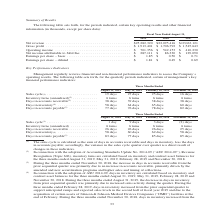According to Jabil Circuit's financial document, What was the net revenue in 2019? According to the financial document, $25,282,320 (in thousands). The relevant text states: "Net revenue . $25,282,320 $22,095,416 $19,063,121 Gross profit . $ 1,913,401 $ 1,706,792 $ 1,545,643 Operating income . $ 701,..." Also, What was the gross profit in 2018? According to the financial document, $1,706,792 (in thousands). The relevant text states: ",095,416 $19,063,121 Gross profit . $ 1,913,401 $ 1,706,792 $ 1,545,643 Operating income . $ 701,356 $ 542,153 $ 410,230 Net income attributable to Jabil Inc...." Also, What was the operating income in 2017? According to the financial document, $410,230 (in thousands). The relevant text states: ",545,643 Operating income . $ 701,356 $ 542,153 $ 410,230 Net income attributable to Jabil Inc. . $ 287,111 $ 86,330 $ 129,090 Earnings per share – basic . $..." Also, How many years did the net revenue exceed $20,000,000 thousand? Counting the relevant items in the document: 2019, 2018, I find 2 instances. The key data points involved are: 2018, 2019. Also, can you calculate: What was the change in gross profit between 2017 and 2018? Based on the calculation: $1,706,792-$1,545,643, the result is 161149 (in thousands). This is based on the information: ",063,121 Gross profit . $ 1,913,401 $ 1,706,792 $ 1,545,643 Operating income . $ 701,356 $ 542,153 $ 410,230 Net income attributable to Jabil Inc. . $ 287,111 ,095,416 $19,063,121 Gross profit . $ 1,9..." The key data points involved are: 1,545,643, 1,706,792. Also, can you calculate: What was the percentage change in operating income between 2018 and 2019? To answer this question, I need to perform calculations using the financial data. The calculation is: ($701,356-$542,153)/$542,153, which equals 29.36 (percentage). This is based on the information: "06,792 $ 1,545,643 Operating income . $ 701,356 $ 542,153 $ 410,230 Net income attributable to Jabil Inc. . $ 287,111 $ 86,330 $ 129,090 Earnings per share – ,401 $ 1,706,792 $ 1,545,643 Operating inc..." The key data points involved are: 542,153, 701,356. 